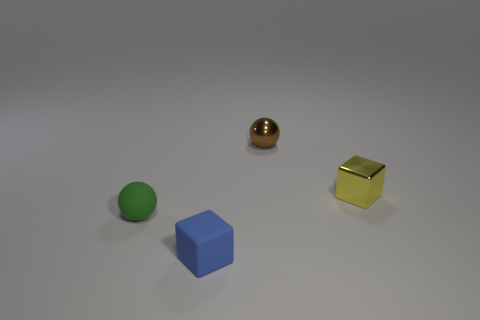Are the tiny yellow block and the small brown sphere that is behind the blue block made of the same material?
Your answer should be compact. Yes. There is a brown ball that is the same size as the yellow metallic block; what is its material?
Offer a very short reply. Metal. Are there any small cyan cubes that have the same material as the brown object?
Provide a short and direct response. No. There is a tiny rubber thing behind the small object that is in front of the small green sphere; is there a thing behind it?
Make the answer very short. Yes. What shape is the green object that is the same size as the brown metal thing?
Your answer should be very brief. Sphere. What number of small blue metallic objects are there?
Provide a succinct answer. 0. How big is the block in front of the ball that is in front of the shiny object right of the brown sphere?
Give a very brief answer. Small. How many tiny brown metallic things are right of the yellow thing?
Provide a short and direct response. 0. Is the number of brown metallic spheres in front of the small yellow metal cube the same as the number of small green cylinders?
Keep it short and to the point. Yes. What number of things are purple cylinders or green objects?
Provide a succinct answer. 1. 